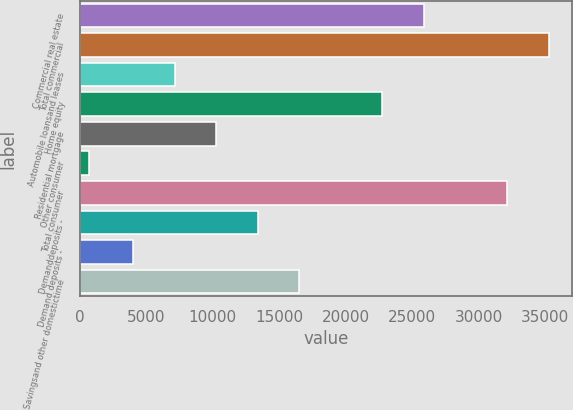Convert chart. <chart><loc_0><loc_0><loc_500><loc_500><bar_chart><fcel>Commercial real estate<fcel>Total commercial<fcel>Automobile loansand leases<fcel>Home equity<fcel>Residential mortgage<fcel>Other consumer<fcel>Total consumer<fcel>Demanddeposits -<fcel>Demand deposits -<fcel>Savingsand other domestictime<nl><fcel>25901.8<fcel>35287<fcel>7131.4<fcel>22773.4<fcel>10259.8<fcel>691<fcel>32158.6<fcel>13388.2<fcel>4003<fcel>16516.6<nl></chart> 